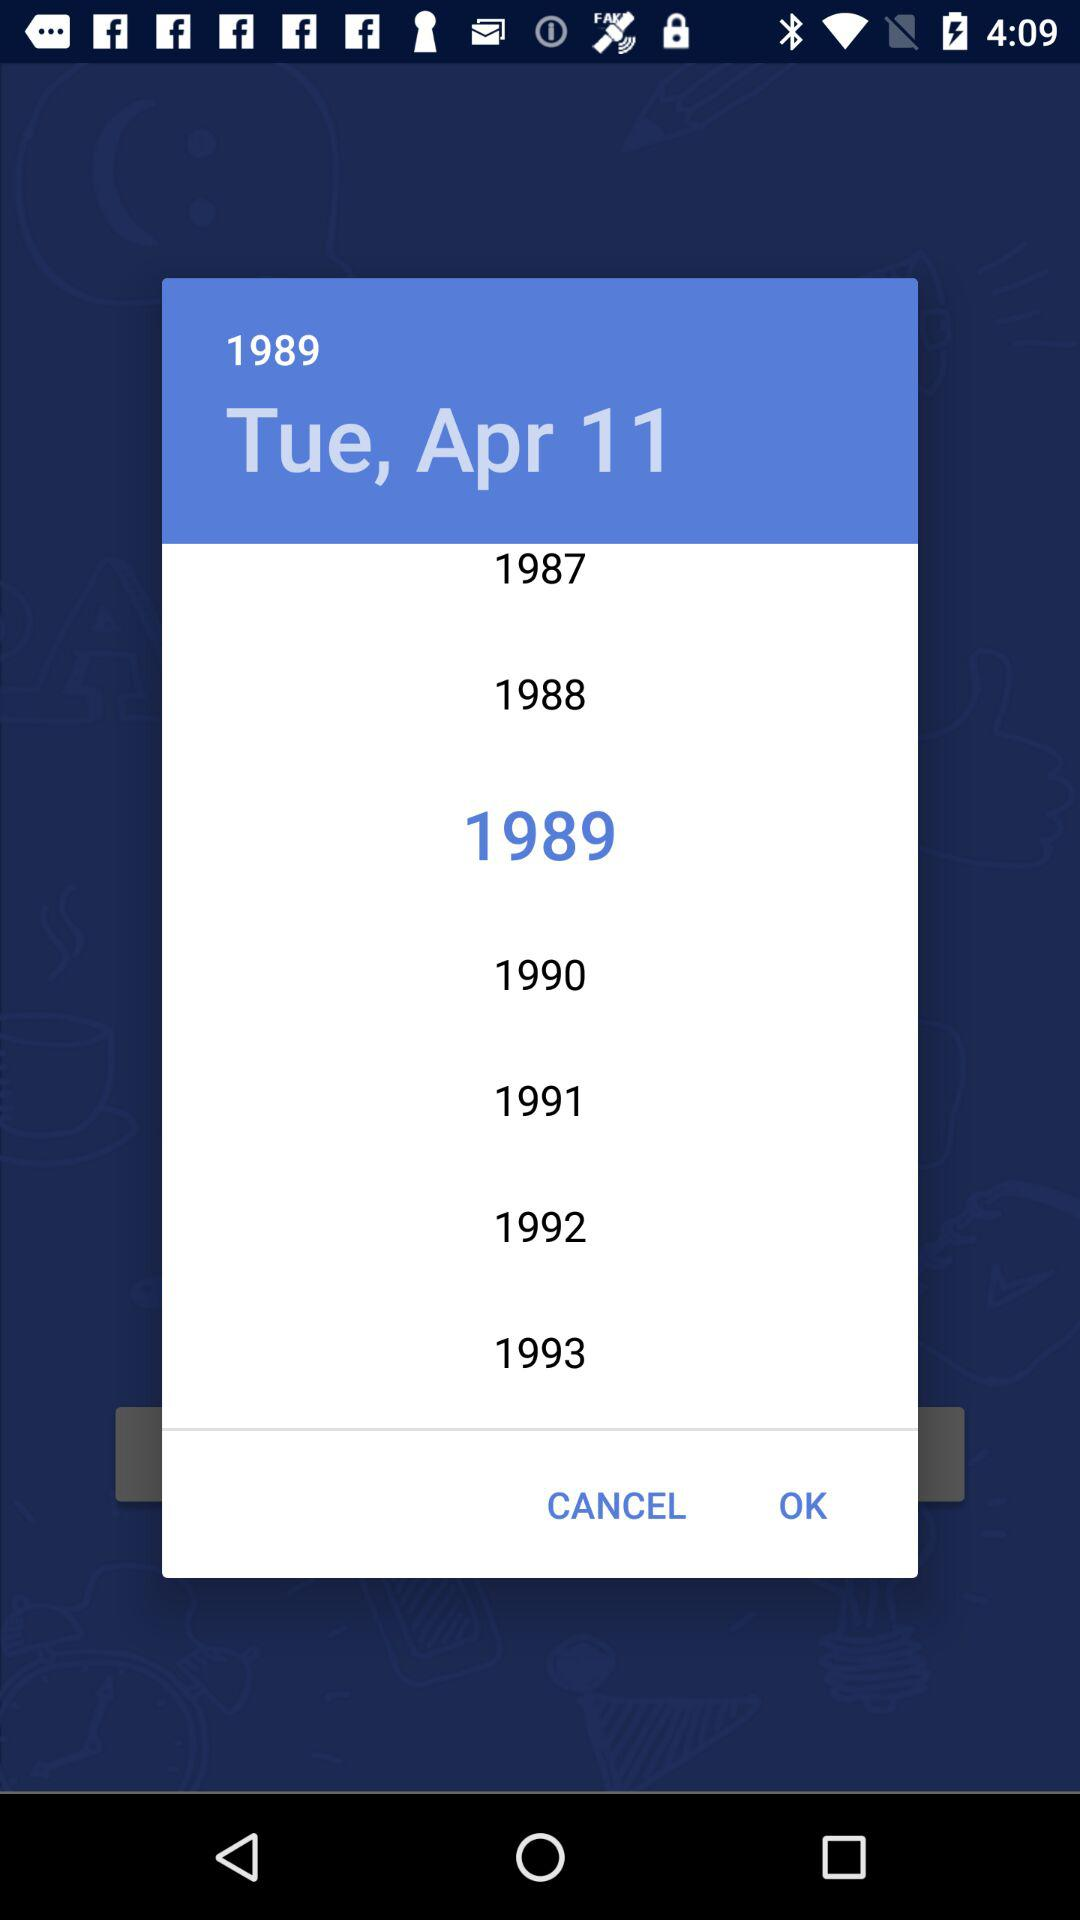What is the month? The month is April. 